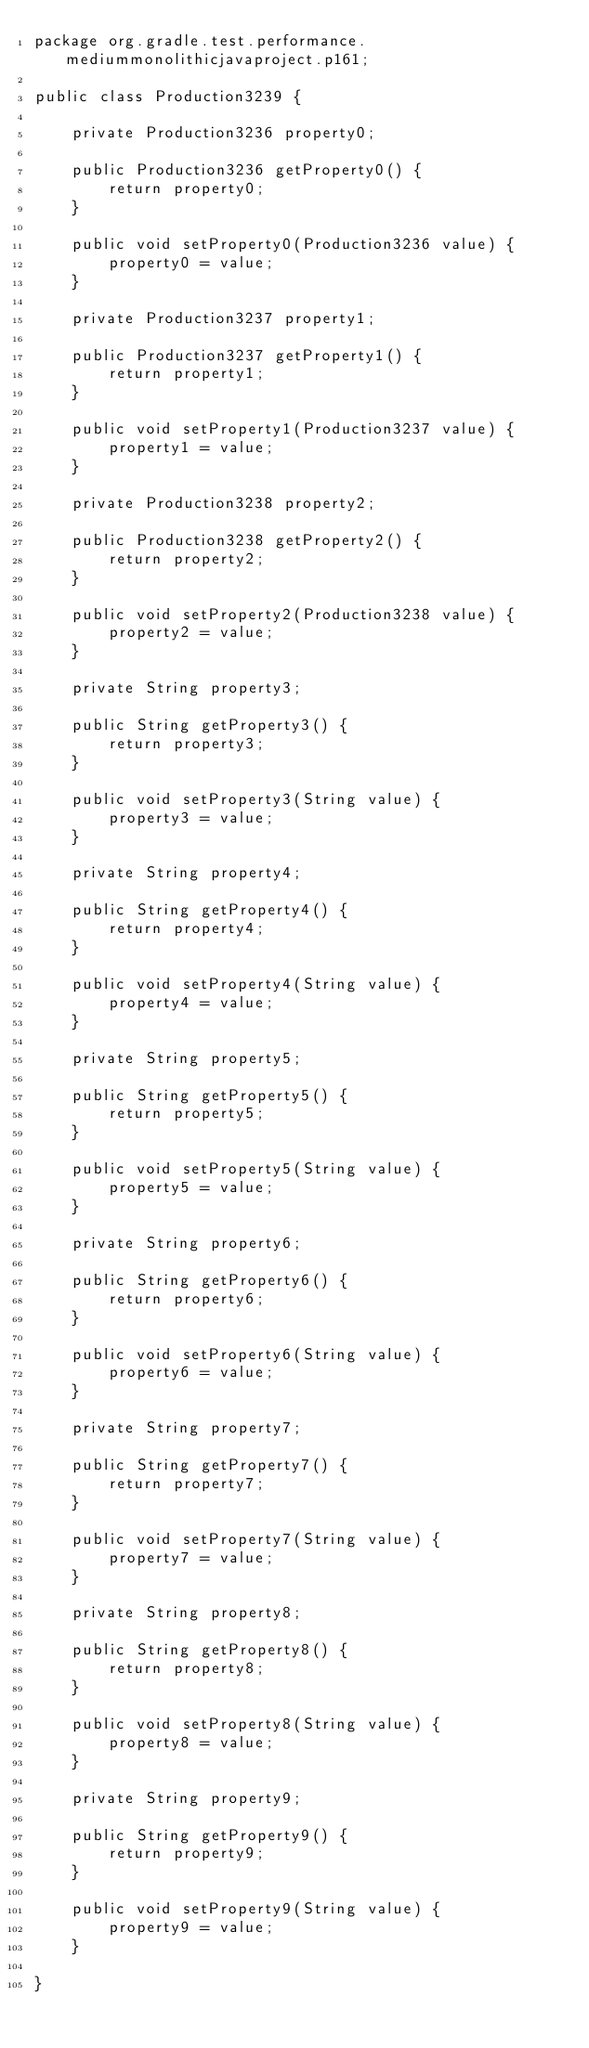Convert code to text. <code><loc_0><loc_0><loc_500><loc_500><_Java_>package org.gradle.test.performance.mediummonolithicjavaproject.p161;

public class Production3239 {        

    private Production3236 property0;

    public Production3236 getProperty0() {
        return property0;
    }

    public void setProperty0(Production3236 value) {
        property0 = value;
    }

    private Production3237 property1;

    public Production3237 getProperty1() {
        return property1;
    }

    public void setProperty1(Production3237 value) {
        property1 = value;
    }

    private Production3238 property2;

    public Production3238 getProperty2() {
        return property2;
    }

    public void setProperty2(Production3238 value) {
        property2 = value;
    }

    private String property3;

    public String getProperty3() {
        return property3;
    }

    public void setProperty3(String value) {
        property3 = value;
    }

    private String property4;

    public String getProperty4() {
        return property4;
    }

    public void setProperty4(String value) {
        property4 = value;
    }

    private String property5;

    public String getProperty5() {
        return property5;
    }

    public void setProperty5(String value) {
        property5 = value;
    }

    private String property6;

    public String getProperty6() {
        return property6;
    }

    public void setProperty6(String value) {
        property6 = value;
    }

    private String property7;

    public String getProperty7() {
        return property7;
    }

    public void setProperty7(String value) {
        property7 = value;
    }

    private String property8;

    public String getProperty8() {
        return property8;
    }

    public void setProperty8(String value) {
        property8 = value;
    }

    private String property9;

    public String getProperty9() {
        return property9;
    }

    public void setProperty9(String value) {
        property9 = value;
    }

}</code> 